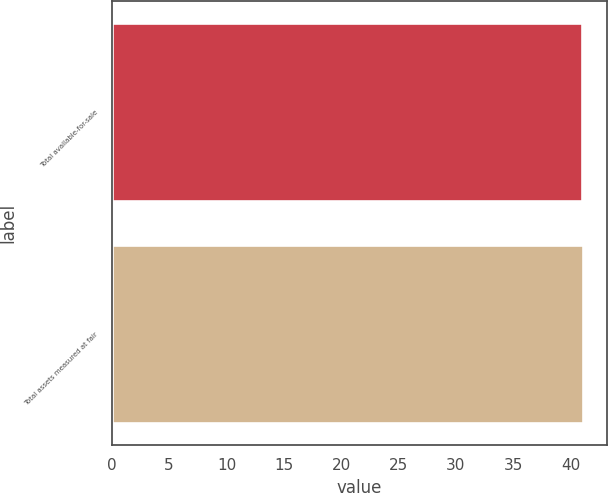Convert chart to OTSL. <chart><loc_0><loc_0><loc_500><loc_500><bar_chart><fcel>Total available-for-sale<fcel>Total assets measured at fair<nl><fcel>41<fcel>41.1<nl></chart> 